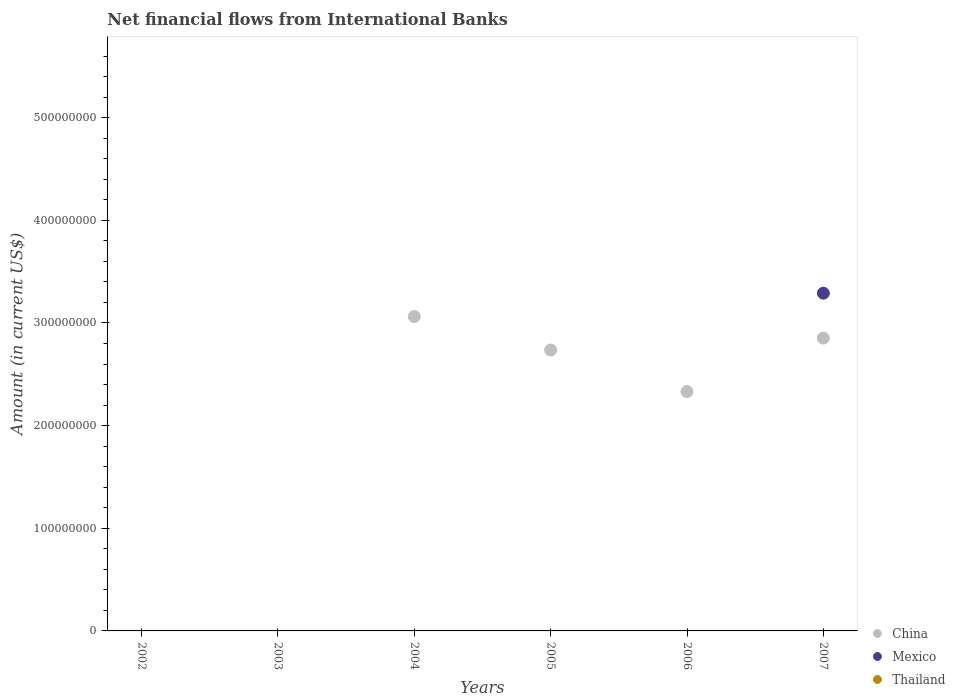How many different coloured dotlines are there?
Offer a terse response. 2. Is the number of dotlines equal to the number of legend labels?
Offer a very short reply. No. Across all years, what is the maximum net financial aid flows in Mexico?
Give a very brief answer. 3.29e+08. Across all years, what is the minimum net financial aid flows in China?
Make the answer very short. 0. What is the total net financial aid flows in China in the graph?
Ensure brevity in your answer.  1.10e+09. What is the difference between the net financial aid flows in Mexico in 2005 and the net financial aid flows in Thailand in 2007?
Make the answer very short. 0. What is the average net financial aid flows in Mexico per year?
Your response must be concise. 5.48e+07. In how many years, is the net financial aid flows in Mexico greater than 220000000 US$?
Give a very brief answer. 1. What is the ratio of the net financial aid flows in China in 2004 to that in 2006?
Offer a very short reply. 1.31. What is the difference between the highest and the lowest net financial aid flows in Mexico?
Ensure brevity in your answer.  3.29e+08. Is the sum of the net financial aid flows in China in 2004 and 2007 greater than the maximum net financial aid flows in Thailand across all years?
Offer a terse response. Yes. Is it the case that in every year, the sum of the net financial aid flows in China and net financial aid flows in Mexico  is greater than the net financial aid flows in Thailand?
Offer a terse response. No. Does the net financial aid flows in Mexico monotonically increase over the years?
Give a very brief answer. No. Is the net financial aid flows in Mexico strictly less than the net financial aid flows in China over the years?
Give a very brief answer. No. How many dotlines are there?
Your answer should be very brief. 2. How many years are there in the graph?
Give a very brief answer. 6. Are the values on the major ticks of Y-axis written in scientific E-notation?
Keep it short and to the point. No. What is the title of the graph?
Give a very brief answer. Net financial flows from International Banks. Does "Romania" appear as one of the legend labels in the graph?
Provide a short and direct response. No. What is the label or title of the X-axis?
Your answer should be very brief. Years. What is the Amount (in current US$) of China in 2002?
Provide a succinct answer. 0. What is the Amount (in current US$) of Mexico in 2002?
Offer a terse response. 0. What is the Amount (in current US$) of Mexico in 2003?
Your answer should be compact. 0. What is the Amount (in current US$) in Thailand in 2003?
Your response must be concise. 0. What is the Amount (in current US$) in China in 2004?
Your response must be concise. 3.06e+08. What is the Amount (in current US$) of Mexico in 2004?
Keep it short and to the point. 0. What is the Amount (in current US$) of Thailand in 2004?
Make the answer very short. 0. What is the Amount (in current US$) in China in 2005?
Your response must be concise. 2.74e+08. What is the Amount (in current US$) of China in 2006?
Provide a short and direct response. 2.33e+08. What is the Amount (in current US$) in Mexico in 2006?
Make the answer very short. 0. What is the Amount (in current US$) in Thailand in 2006?
Provide a succinct answer. 0. What is the Amount (in current US$) of China in 2007?
Provide a succinct answer. 2.85e+08. What is the Amount (in current US$) in Mexico in 2007?
Provide a succinct answer. 3.29e+08. What is the Amount (in current US$) in Thailand in 2007?
Your response must be concise. 0. Across all years, what is the maximum Amount (in current US$) in China?
Provide a short and direct response. 3.06e+08. Across all years, what is the maximum Amount (in current US$) in Mexico?
Give a very brief answer. 3.29e+08. Across all years, what is the minimum Amount (in current US$) of China?
Offer a very short reply. 0. Across all years, what is the minimum Amount (in current US$) in Mexico?
Provide a succinct answer. 0. What is the total Amount (in current US$) of China in the graph?
Provide a short and direct response. 1.10e+09. What is the total Amount (in current US$) in Mexico in the graph?
Your response must be concise. 3.29e+08. What is the total Amount (in current US$) in Thailand in the graph?
Provide a succinct answer. 0. What is the difference between the Amount (in current US$) in China in 2004 and that in 2005?
Your answer should be very brief. 3.26e+07. What is the difference between the Amount (in current US$) of China in 2004 and that in 2006?
Your answer should be very brief. 7.30e+07. What is the difference between the Amount (in current US$) in China in 2004 and that in 2007?
Give a very brief answer. 2.10e+07. What is the difference between the Amount (in current US$) in China in 2005 and that in 2006?
Offer a terse response. 4.05e+07. What is the difference between the Amount (in current US$) in China in 2005 and that in 2007?
Your response must be concise. -1.16e+07. What is the difference between the Amount (in current US$) in China in 2006 and that in 2007?
Keep it short and to the point. -5.21e+07. What is the difference between the Amount (in current US$) in China in 2004 and the Amount (in current US$) in Mexico in 2007?
Your answer should be compact. -2.28e+07. What is the difference between the Amount (in current US$) of China in 2005 and the Amount (in current US$) of Mexico in 2007?
Keep it short and to the point. -5.53e+07. What is the difference between the Amount (in current US$) of China in 2006 and the Amount (in current US$) of Mexico in 2007?
Your answer should be compact. -9.58e+07. What is the average Amount (in current US$) of China per year?
Offer a very short reply. 1.83e+08. What is the average Amount (in current US$) in Mexico per year?
Provide a short and direct response. 5.48e+07. In the year 2007, what is the difference between the Amount (in current US$) of China and Amount (in current US$) of Mexico?
Your answer should be compact. -4.37e+07. What is the ratio of the Amount (in current US$) of China in 2004 to that in 2005?
Provide a succinct answer. 1.12. What is the ratio of the Amount (in current US$) in China in 2004 to that in 2006?
Ensure brevity in your answer.  1.31. What is the ratio of the Amount (in current US$) in China in 2004 to that in 2007?
Make the answer very short. 1.07. What is the ratio of the Amount (in current US$) in China in 2005 to that in 2006?
Provide a short and direct response. 1.17. What is the ratio of the Amount (in current US$) of China in 2005 to that in 2007?
Provide a short and direct response. 0.96. What is the ratio of the Amount (in current US$) of China in 2006 to that in 2007?
Provide a succinct answer. 0.82. What is the difference between the highest and the second highest Amount (in current US$) of China?
Your answer should be very brief. 2.10e+07. What is the difference between the highest and the lowest Amount (in current US$) of China?
Offer a terse response. 3.06e+08. What is the difference between the highest and the lowest Amount (in current US$) in Mexico?
Ensure brevity in your answer.  3.29e+08. 